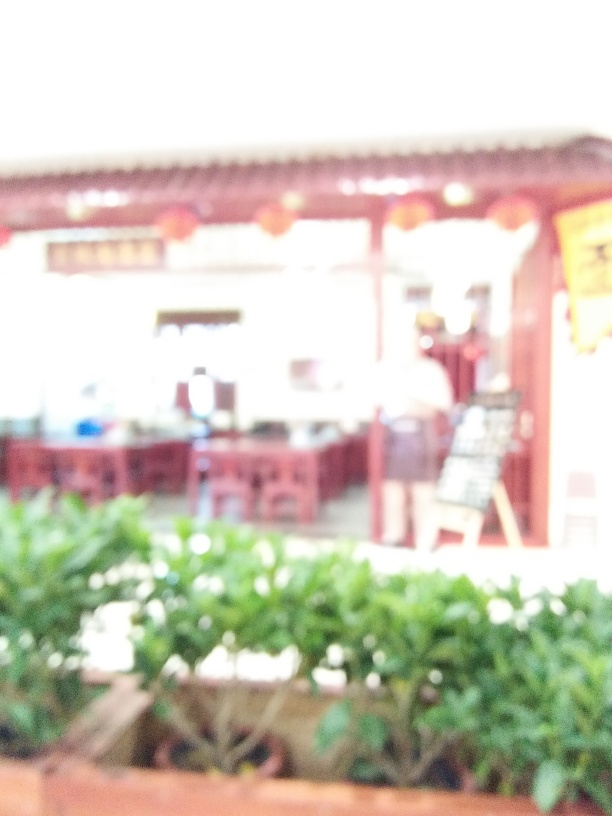Can you guess the time of day this photo was taken? Given the overall brightness and the lack of strong shadows or artificial light sources, it's plausible that the photograph was taken during daylight hours, although the exact time cannot be determined with certainty. 